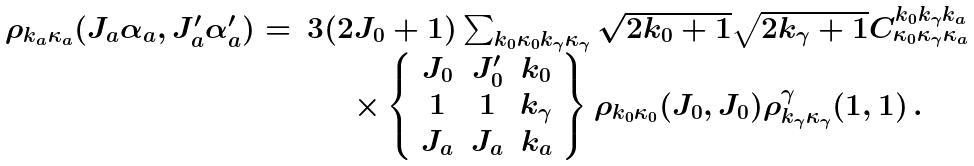Convert formula to latex. <formula><loc_0><loc_0><loc_500><loc_500>\begin{array} { c c } \rho _ { k _ { a } \kappa _ { a } } ( J _ { a } \alpha _ { a } , J ^ { \prime } _ { a } \alpha ^ { \prime } _ { a } ) = & 3 ( 2 J _ { 0 } + 1 ) \sum _ { k _ { 0 } \kappa _ { 0 } k _ { \gamma } \kappa _ { \gamma } } \sqrt { 2 k _ { 0 } + 1 } \sqrt { 2 k _ { \gamma } + 1 } C _ { \kappa _ { 0 } \kappa _ { \gamma } \kappa _ { a } } ^ { k _ { 0 } k _ { \gamma } k _ { a } } \\ & \times \left \{ \begin{array} { c c c } J _ { 0 } & J ^ { \prime } _ { 0 } & k _ { 0 } \\ 1 & 1 & k _ { \gamma } \\ J _ { a } & J _ { a } & k _ { a } \end{array} \right \} \rho _ { k _ { 0 } \kappa _ { 0 } } ( J _ { 0 } , J _ { 0 } ) \rho _ { k _ { \gamma } \kappa _ { \gamma } } ^ { \gamma } ( 1 , 1 ) \, . \end{array}</formula> 